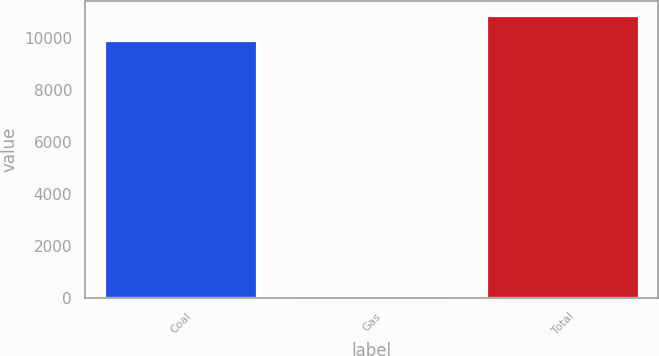<chart> <loc_0><loc_0><loc_500><loc_500><bar_chart><fcel>Coal<fcel>Gas<fcel>Total<nl><fcel>9924<fcel>85<fcel>10916.4<nl></chart> 